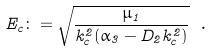Convert formula to latex. <formula><loc_0><loc_0><loc_500><loc_500>E _ { c } \colon = \sqrt { \frac { \mu _ { 1 } } { k _ { c } ^ { 2 } ( \alpha _ { 3 } - D _ { 2 } k _ { c } ^ { 2 } ) } } \ .</formula> 